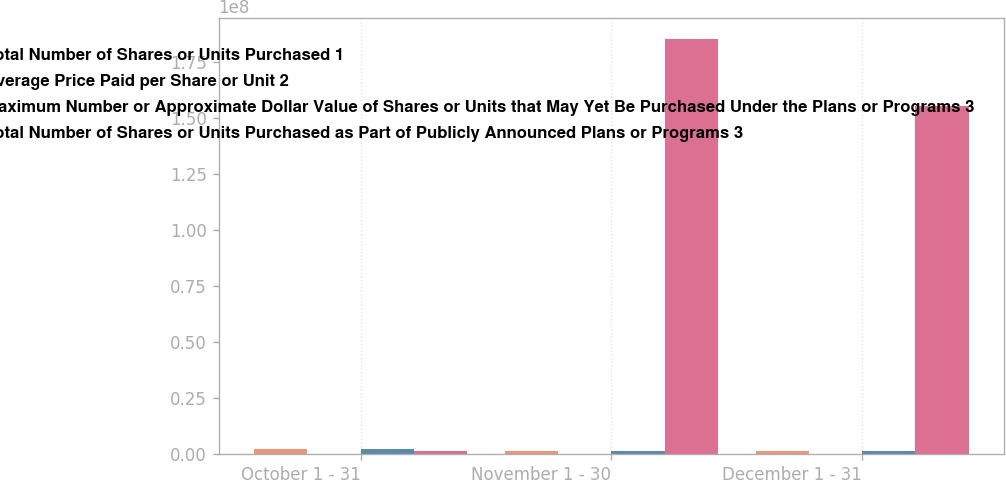Convert chart. <chart><loc_0><loc_0><loc_500><loc_500><stacked_bar_chart><ecel><fcel>October 1 - 31<fcel>November 1 - 30<fcel>December 1 - 31<nl><fcel>Total Number of Shares or Units Purchased 1<fcel>2.09917e+06<fcel>1.4544e+06<fcel>1.26945e+06<nl><fcel>Average Price Paid per Share or Unit 2<fcel>22.28<fcel>22.79<fcel>23.93<nl><fcel>Maximum Number or Approximate Dollar Value of Shares or Units that May Yet Be Purchased Under the Plans or Programs 3<fcel>2.09917e+06<fcel>1.45305e+06<fcel>1.2587e+06<nl><fcel>Total Number of Shares or Units Purchased as Part of Publicly Announced Plans or Programs 3<fcel>1.45305e+06<fcel>1.85501e+08<fcel>1.55371e+08<nl></chart> 